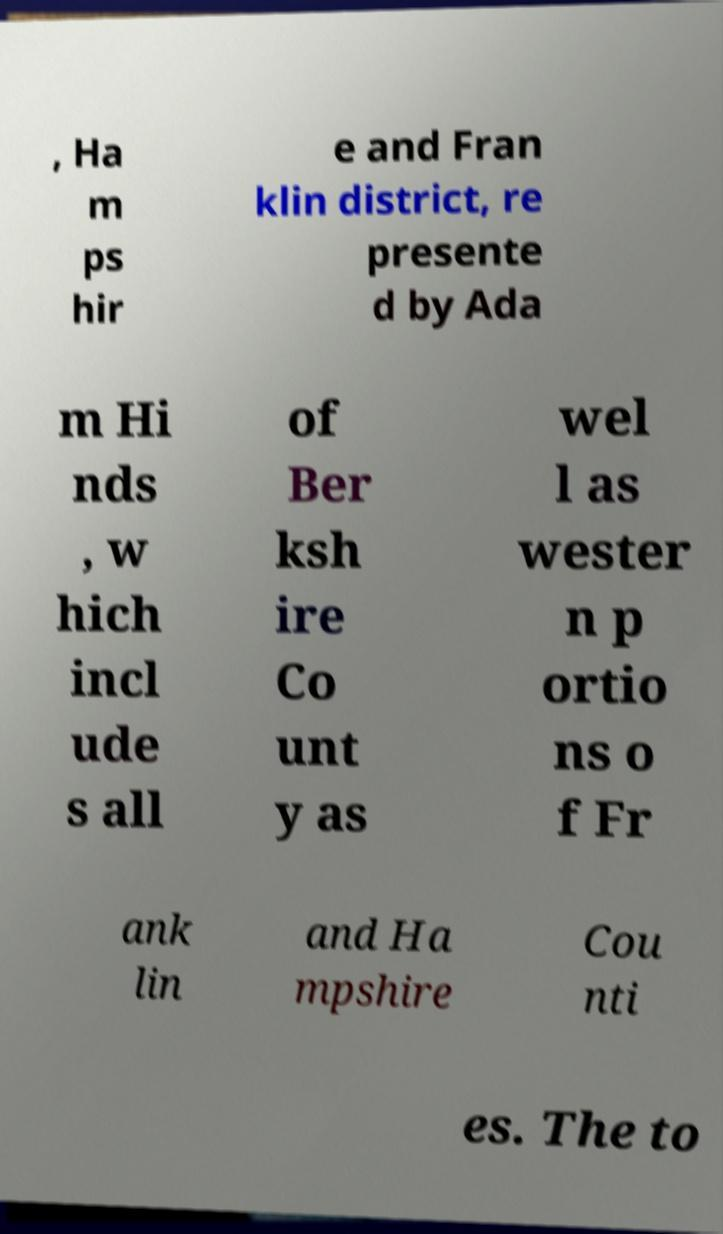Can you read and provide the text displayed in the image?This photo seems to have some interesting text. Can you extract and type it out for me? , Ha m ps hir e and Fran klin district, re presente d by Ada m Hi nds , w hich incl ude s all of Ber ksh ire Co unt y as wel l as wester n p ortio ns o f Fr ank lin and Ha mpshire Cou nti es. The to 